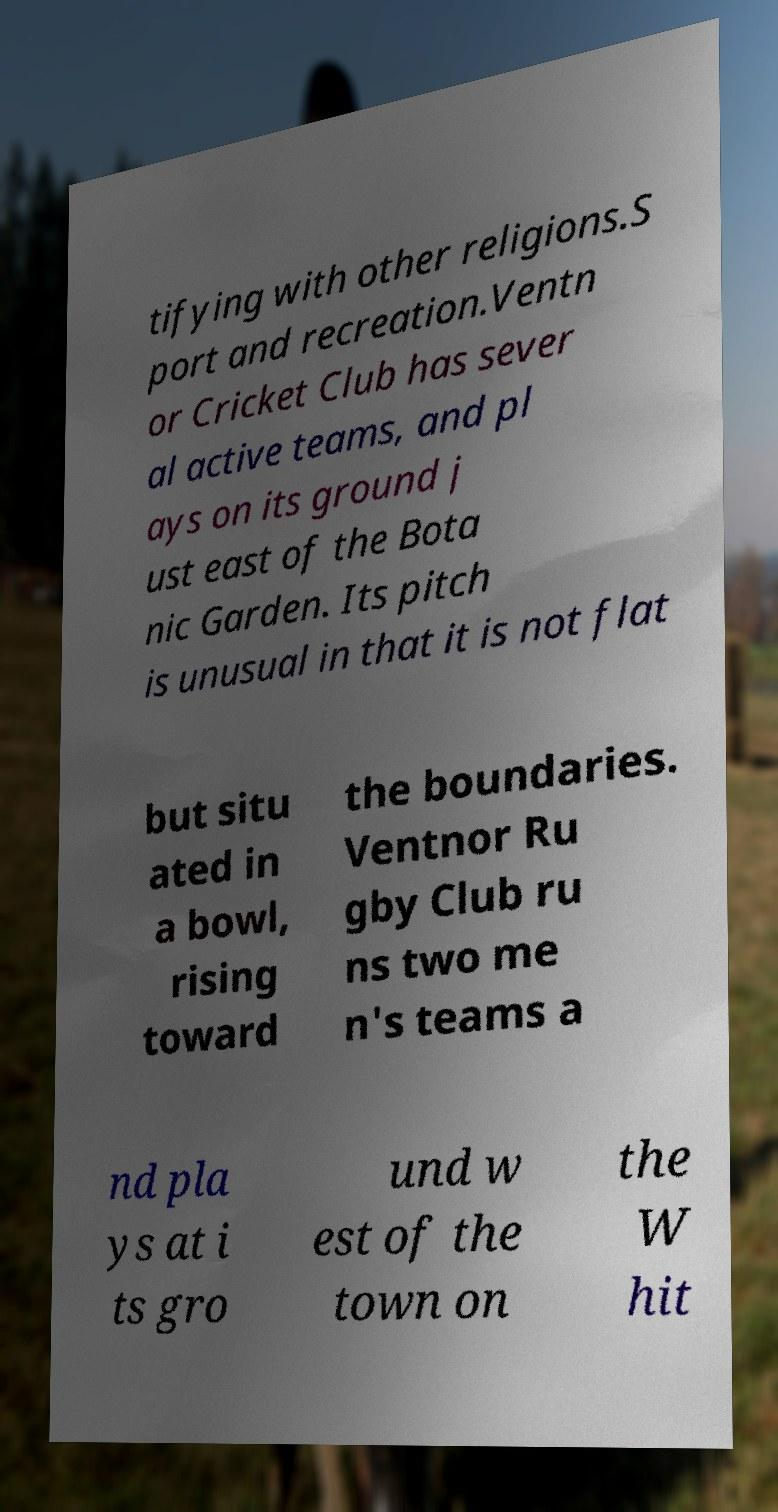I need the written content from this picture converted into text. Can you do that? tifying with other religions.S port and recreation.Ventn or Cricket Club has sever al active teams, and pl ays on its ground j ust east of the Bota nic Garden. Its pitch is unusual in that it is not flat but situ ated in a bowl, rising toward the boundaries. Ventnor Ru gby Club ru ns two me n's teams a nd pla ys at i ts gro und w est of the town on the W hit 